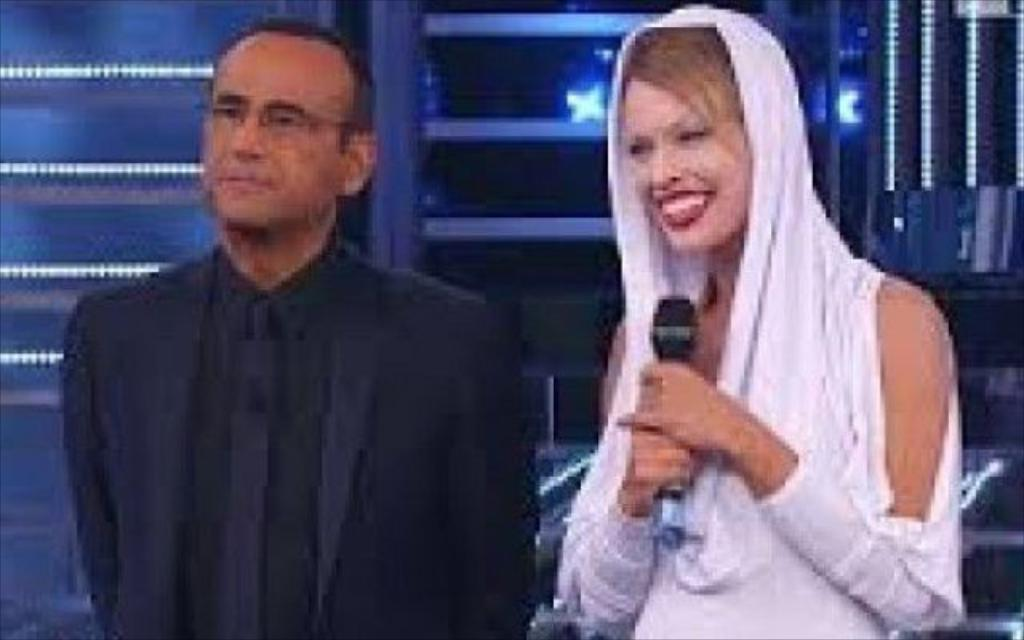How many people are present in the image? There are two people in the image, a man and a woman. What is the woman holding in her hands? The woman is holding a microphone in her hands. What can be seen in the background of the image? There are lights visible in the background of the image. Can you see a cat playing with a rifle in the image? No, there is no cat or rifle present in the image. 